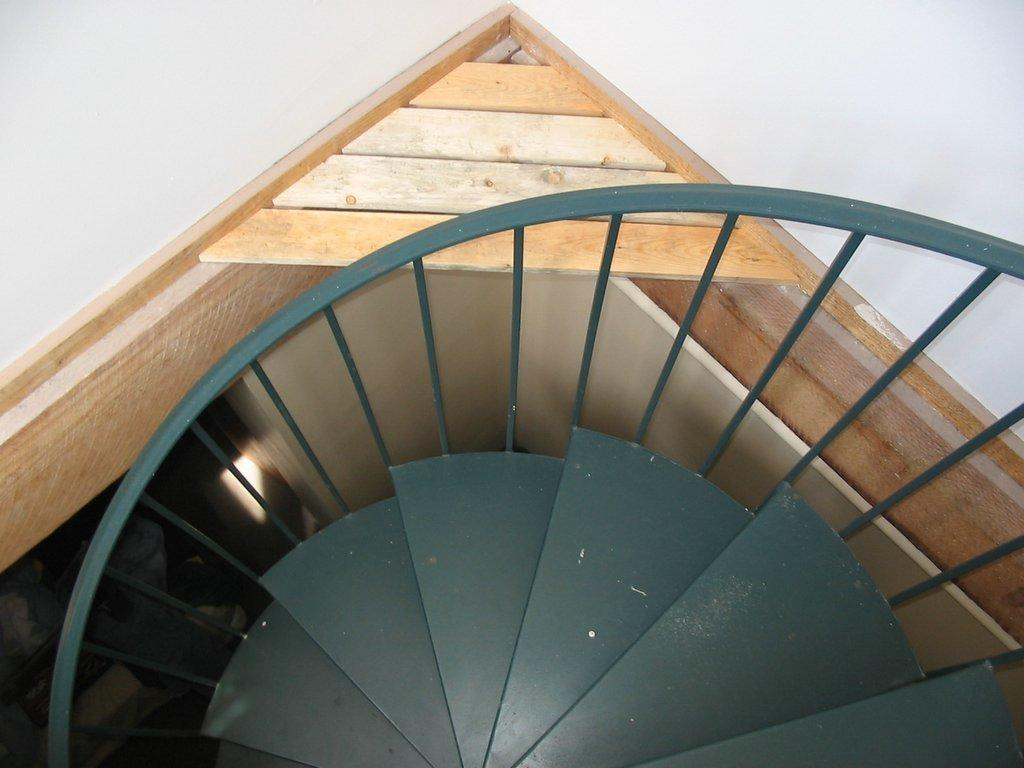What type of architectural feature is present in the image? There are stairs in the image. What accompanies the stairs in the image? There is a railing in the image. What can be seen in the background of the image? There is a room visible in the background of the image. What is present in the room in the background? There are objects present in the room in the background. How many fingers can be seen smashing the sock in the image? There are no fingers or socks present in the image; it features stairs with a railing and a room in the background. 